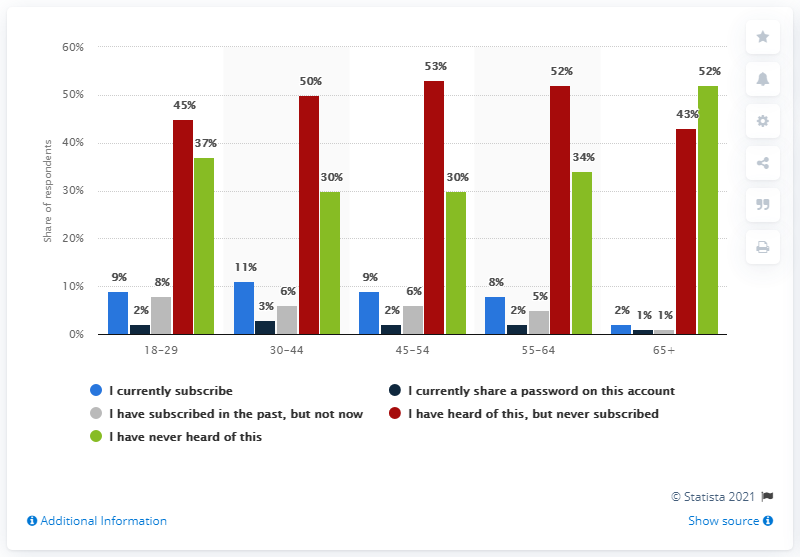Give some essential details in this illustration. Approximately 11% of respondents reported currently subscribing to Vudu. 